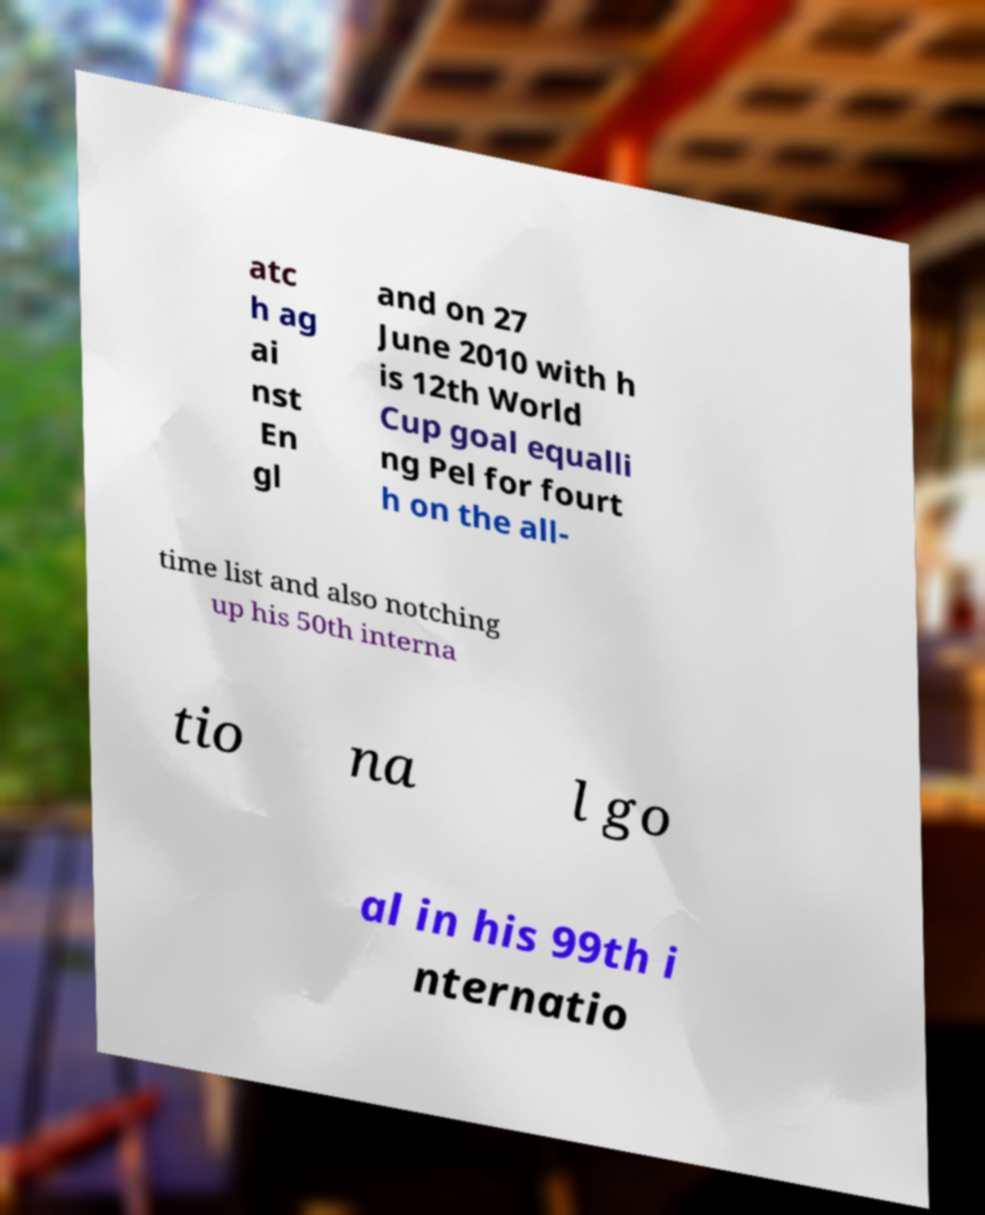Can you read and provide the text displayed in the image?This photo seems to have some interesting text. Can you extract and type it out for me? atc h ag ai nst En gl and on 27 June 2010 with h is 12th World Cup goal equalli ng Pel for fourt h on the all- time list and also notching up his 50th interna tio na l go al in his 99th i nternatio 